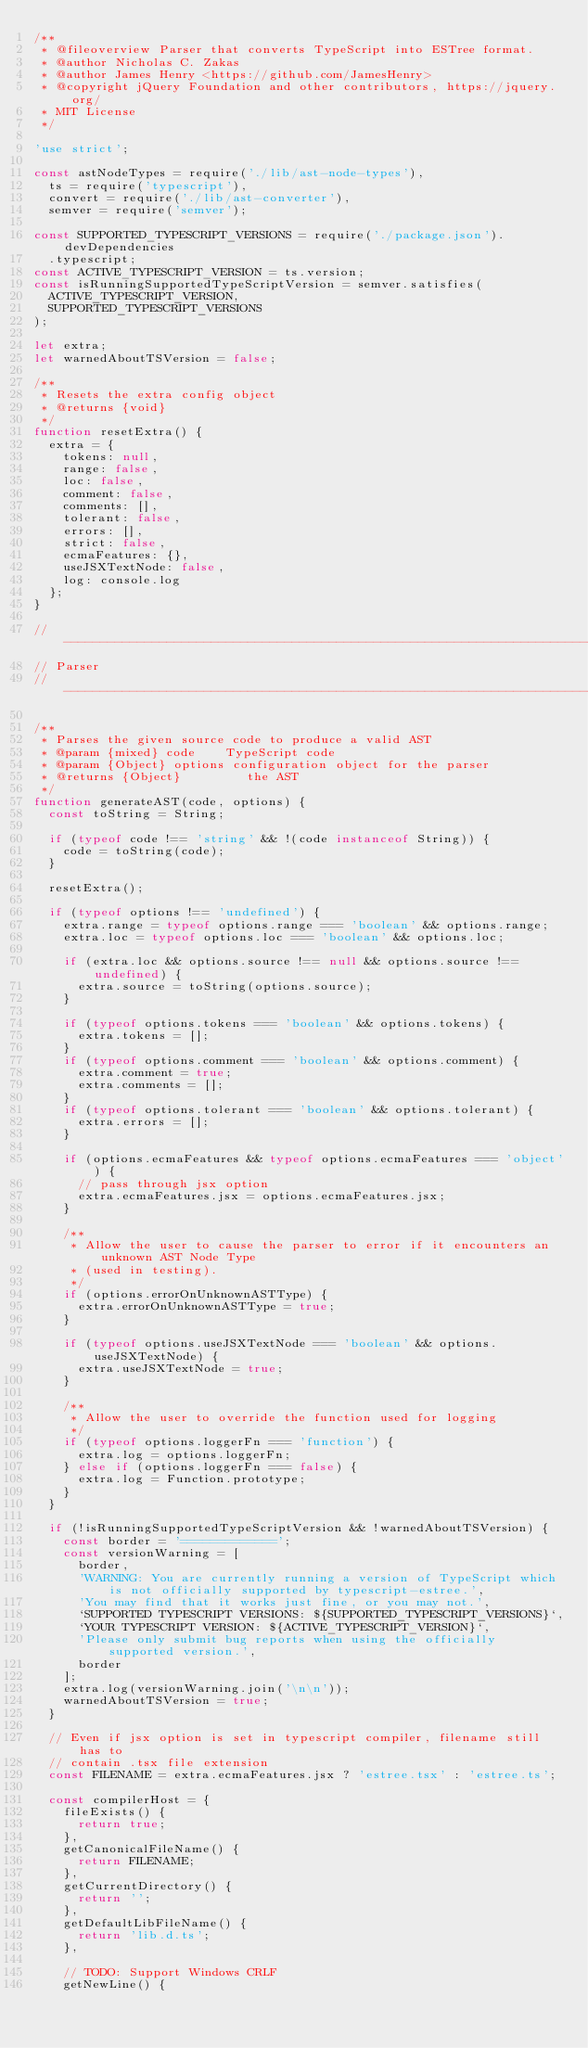Convert code to text. <code><loc_0><loc_0><loc_500><loc_500><_JavaScript_>/**
 * @fileoverview Parser that converts TypeScript into ESTree format.
 * @author Nicholas C. Zakas
 * @author James Henry <https://github.com/JamesHenry>
 * @copyright jQuery Foundation and other contributors, https://jquery.org/
 * MIT License
 */

'use strict';

const astNodeTypes = require('./lib/ast-node-types'),
  ts = require('typescript'),
  convert = require('./lib/ast-converter'),
  semver = require('semver');

const SUPPORTED_TYPESCRIPT_VERSIONS = require('./package.json').devDependencies
  .typescript;
const ACTIVE_TYPESCRIPT_VERSION = ts.version;
const isRunningSupportedTypeScriptVersion = semver.satisfies(
  ACTIVE_TYPESCRIPT_VERSION,
  SUPPORTED_TYPESCRIPT_VERSIONS
);

let extra;
let warnedAboutTSVersion = false;

/**
 * Resets the extra config object
 * @returns {void}
 */
function resetExtra() {
  extra = {
    tokens: null,
    range: false,
    loc: false,
    comment: false,
    comments: [],
    tolerant: false,
    errors: [],
    strict: false,
    ecmaFeatures: {},
    useJSXTextNode: false,
    log: console.log
  };
}

//------------------------------------------------------------------------------
// Parser
//------------------------------------------------------------------------------

/**
 * Parses the given source code to produce a valid AST
 * @param {mixed} code    TypeScript code
 * @param {Object} options configuration object for the parser
 * @returns {Object}         the AST
 */
function generateAST(code, options) {
  const toString = String;

  if (typeof code !== 'string' && !(code instanceof String)) {
    code = toString(code);
  }

  resetExtra();

  if (typeof options !== 'undefined') {
    extra.range = typeof options.range === 'boolean' && options.range;
    extra.loc = typeof options.loc === 'boolean' && options.loc;

    if (extra.loc && options.source !== null && options.source !== undefined) {
      extra.source = toString(options.source);
    }

    if (typeof options.tokens === 'boolean' && options.tokens) {
      extra.tokens = [];
    }
    if (typeof options.comment === 'boolean' && options.comment) {
      extra.comment = true;
      extra.comments = [];
    }
    if (typeof options.tolerant === 'boolean' && options.tolerant) {
      extra.errors = [];
    }

    if (options.ecmaFeatures && typeof options.ecmaFeatures === 'object') {
      // pass through jsx option
      extra.ecmaFeatures.jsx = options.ecmaFeatures.jsx;
    }

    /**
     * Allow the user to cause the parser to error if it encounters an unknown AST Node Type
     * (used in testing).
     */
    if (options.errorOnUnknownASTType) {
      extra.errorOnUnknownASTType = true;
    }

    if (typeof options.useJSXTextNode === 'boolean' && options.useJSXTextNode) {
      extra.useJSXTextNode = true;
    }

    /**
     * Allow the user to override the function used for logging
     */
    if (typeof options.loggerFn === 'function') {
      extra.log = options.loggerFn;
    } else if (options.loggerFn === false) {
      extra.log = Function.prototype;
    }
  }

  if (!isRunningSupportedTypeScriptVersion && !warnedAboutTSVersion) {
    const border = '=============';
    const versionWarning = [
      border,
      'WARNING: You are currently running a version of TypeScript which is not officially supported by typescript-estree.',
      'You may find that it works just fine, or you may not.',
      `SUPPORTED TYPESCRIPT VERSIONS: ${SUPPORTED_TYPESCRIPT_VERSIONS}`,
      `YOUR TYPESCRIPT VERSION: ${ACTIVE_TYPESCRIPT_VERSION}`,
      'Please only submit bug reports when using the officially supported version.',
      border
    ];
    extra.log(versionWarning.join('\n\n'));
    warnedAboutTSVersion = true;
  }

  // Even if jsx option is set in typescript compiler, filename still has to
  // contain .tsx file extension
  const FILENAME = extra.ecmaFeatures.jsx ? 'estree.tsx' : 'estree.ts';

  const compilerHost = {
    fileExists() {
      return true;
    },
    getCanonicalFileName() {
      return FILENAME;
    },
    getCurrentDirectory() {
      return '';
    },
    getDefaultLibFileName() {
      return 'lib.d.ts';
    },

    // TODO: Support Windows CRLF
    getNewLine() {</code> 